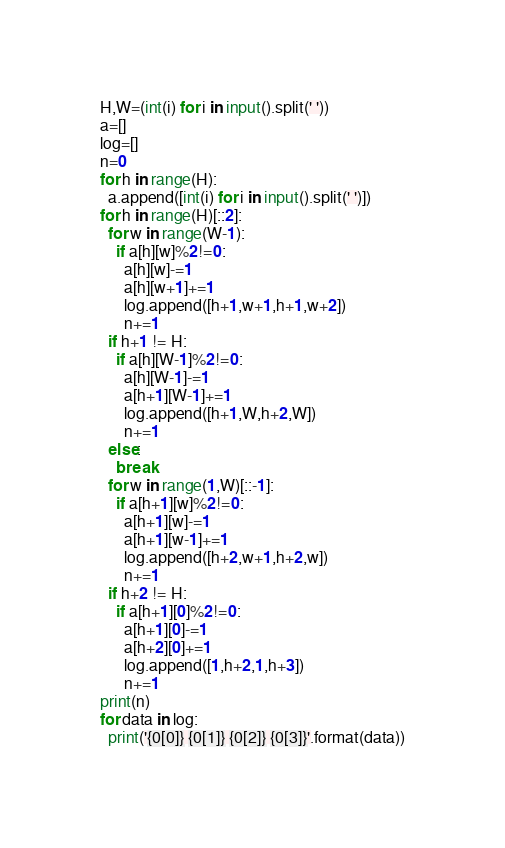Convert code to text. <code><loc_0><loc_0><loc_500><loc_500><_Python_>H,W=(int(i) for i in input().split(' '))
a=[]
log=[]
n=0
for h in range(H):
  a.append([int(i) for i in input().split(' ')])
for h in range(H)[::2]:
  for w in range(W-1):
    if a[h][w]%2!=0:
      a[h][w]-=1
      a[h][w+1]+=1
      log.append([h+1,w+1,h+1,w+2])
      n+=1
  if h+1 != H:
    if a[h][W-1]%2!=0:
      a[h][W-1]-=1
      a[h+1][W-1]+=1
      log.append([h+1,W,h+2,W])
      n+=1
  else:
    break
  for w in range(1,W)[::-1]:
    if a[h+1][w]%2!=0:
      a[h+1][w]-=1
      a[h+1][w-1]+=1
      log.append([h+2,w+1,h+2,w])
      n+=1
  if h+2 != H:
    if a[h+1][0]%2!=0:
      a[h+1][0]-=1
      a[h+2][0]+=1
      log.append([1,h+2,1,h+3])
      n+=1
print(n)
for data in log:
  print('{0[0]} {0[1]} {0[2]} {0[3]}'.format(data))</code> 